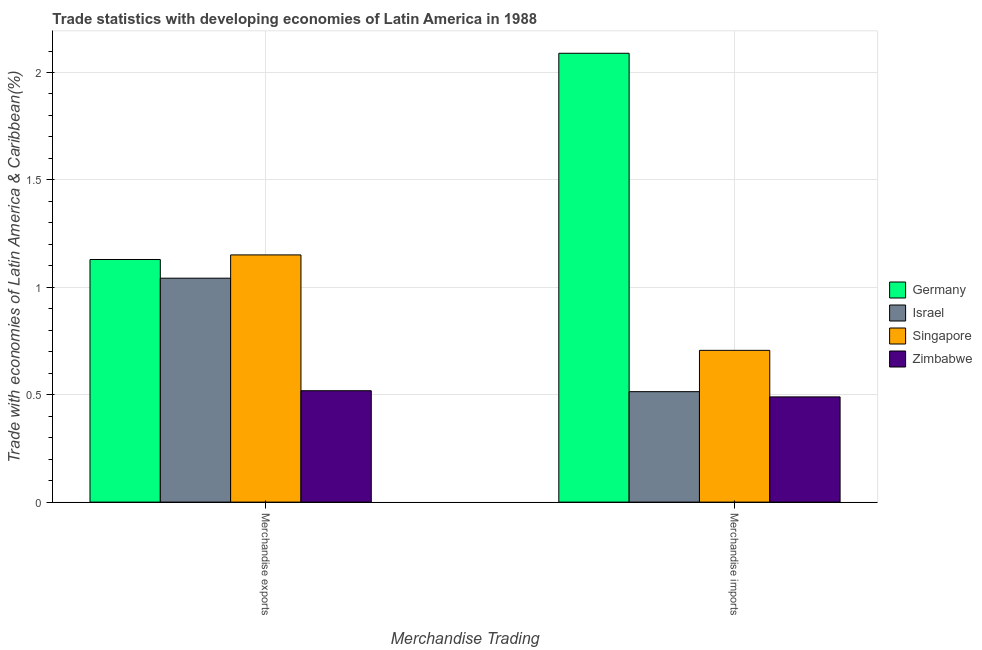How many bars are there on the 1st tick from the left?
Ensure brevity in your answer.  4. How many bars are there on the 1st tick from the right?
Your response must be concise. 4. What is the merchandise imports in Zimbabwe?
Provide a short and direct response. 0.49. Across all countries, what is the maximum merchandise exports?
Provide a short and direct response. 1.15. Across all countries, what is the minimum merchandise imports?
Make the answer very short. 0.49. In which country was the merchandise exports minimum?
Ensure brevity in your answer.  Zimbabwe. What is the total merchandise exports in the graph?
Your response must be concise. 3.84. What is the difference between the merchandise exports in Israel and that in Zimbabwe?
Offer a terse response. 0.52. What is the difference between the merchandise exports in Israel and the merchandise imports in Zimbabwe?
Keep it short and to the point. 0.55. What is the average merchandise imports per country?
Make the answer very short. 0.95. What is the difference between the merchandise exports and merchandise imports in Israel?
Offer a terse response. 0.53. In how many countries, is the merchandise imports greater than 1.4 %?
Make the answer very short. 1. What is the ratio of the merchandise exports in Israel to that in Germany?
Offer a very short reply. 0.92. Is the merchandise exports in Singapore less than that in Germany?
Keep it short and to the point. No. What does the 1st bar from the right in Merchandise imports represents?
Offer a very short reply. Zimbabwe. How many countries are there in the graph?
Offer a terse response. 4. What is the difference between two consecutive major ticks on the Y-axis?
Give a very brief answer. 0.5. Are the values on the major ticks of Y-axis written in scientific E-notation?
Offer a terse response. No. How are the legend labels stacked?
Your response must be concise. Vertical. What is the title of the graph?
Offer a terse response. Trade statistics with developing economies of Latin America in 1988. What is the label or title of the X-axis?
Give a very brief answer. Merchandise Trading. What is the label or title of the Y-axis?
Your response must be concise. Trade with economies of Latin America & Caribbean(%). What is the Trade with economies of Latin America & Caribbean(%) in Germany in Merchandise exports?
Your answer should be compact. 1.13. What is the Trade with economies of Latin America & Caribbean(%) in Israel in Merchandise exports?
Your response must be concise. 1.04. What is the Trade with economies of Latin America & Caribbean(%) of Singapore in Merchandise exports?
Offer a terse response. 1.15. What is the Trade with economies of Latin America & Caribbean(%) of Zimbabwe in Merchandise exports?
Provide a succinct answer. 0.52. What is the Trade with economies of Latin America & Caribbean(%) in Germany in Merchandise imports?
Give a very brief answer. 2.09. What is the Trade with economies of Latin America & Caribbean(%) in Israel in Merchandise imports?
Keep it short and to the point. 0.51. What is the Trade with economies of Latin America & Caribbean(%) in Singapore in Merchandise imports?
Offer a very short reply. 0.71. What is the Trade with economies of Latin America & Caribbean(%) of Zimbabwe in Merchandise imports?
Offer a very short reply. 0.49. Across all Merchandise Trading, what is the maximum Trade with economies of Latin America & Caribbean(%) of Germany?
Offer a terse response. 2.09. Across all Merchandise Trading, what is the maximum Trade with economies of Latin America & Caribbean(%) of Israel?
Ensure brevity in your answer.  1.04. Across all Merchandise Trading, what is the maximum Trade with economies of Latin America & Caribbean(%) in Singapore?
Your answer should be very brief. 1.15. Across all Merchandise Trading, what is the maximum Trade with economies of Latin America & Caribbean(%) of Zimbabwe?
Make the answer very short. 0.52. Across all Merchandise Trading, what is the minimum Trade with economies of Latin America & Caribbean(%) of Germany?
Your answer should be compact. 1.13. Across all Merchandise Trading, what is the minimum Trade with economies of Latin America & Caribbean(%) in Israel?
Keep it short and to the point. 0.51. Across all Merchandise Trading, what is the minimum Trade with economies of Latin America & Caribbean(%) of Singapore?
Offer a very short reply. 0.71. Across all Merchandise Trading, what is the minimum Trade with economies of Latin America & Caribbean(%) in Zimbabwe?
Your answer should be compact. 0.49. What is the total Trade with economies of Latin America & Caribbean(%) in Germany in the graph?
Give a very brief answer. 3.22. What is the total Trade with economies of Latin America & Caribbean(%) of Israel in the graph?
Offer a terse response. 1.56. What is the total Trade with economies of Latin America & Caribbean(%) in Singapore in the graph?
Make the answer very short. 1.86. What is the total Trade with economies of Latin America & Caribbean(%) in Zimbabwe in the graph?
Ensure brevity in your answer.  1.01. What is the difference between the Trade with economies of Latin America & Caribbean(%) in Germany in Merchandise exports and that in Merchandise imports?
Ensure brevity in your answer.  -0.96. What is the difference between the Trade with economies of Latin America & Caribbean(%) of Israel in Merchandise exports and that in Merchandise imports?
Make the answer very short. 0.53. What is the difference between the Trade with economies of Latin America & Caribbean(%) of Singapore in Merchandise exports and that in Merchandise imports?
Keep it short and to the point. 0.44. What is the difference between the Trade with economies of Latin America & Caribbean(%) in Zimbabwe in Merchandise exports and that in Merchandise imports?
Offer a very short reply. 0.03. What is the difference between the Trade with economies of Latin America & Caribbean(%) in Germany in Merchandise exports and the Trade with economies of Latin America & Caribbean(%) in Israel in Merchandise imports?
Your answer should be very brief. 0.62. What is the difference between the Trade with economies of Latin America & Caribbean(%) of Germany in Merchandise exports and the Trade with economies of Latin America & Caribbean(%) of Singapore in Merchandise imports?
Keep it short and to the point. 0.42. What is the difference between the Trade with economies of Latin America & Caribbean(%) in Germany in Merchandise exports and the Trade with economies of Latin America & Caribbean(%) in Zimbabwe in Merchandise imports?
Make the answer very short. 0.64. What is the difference between the Trade with economies of Latin America & Caribbean(%) of Israel in Merchandise exports and the Trade with economies of Latin America & Caribbean(%) of Singapore in Merchandise imports?
Provide a succinct answer. 0.34. What is the difference between the Trade with economies of Latin America & Caribbean(%) of Israel in Merchandise exports and the Trade with economies of Latin America & Caribbean(%) of Zimbabwe in Merchandise imports?
Ensure brevity in your answer.  0.55. What is the difference between the Trade with economies of Latin America & Caribbean(%) in Singapore in Merchandise exports and the Trade with economies of Latin America & Caribbean(%) in Zimbabwe in Merchandise imports?
Make the answer very short. 0.66. What is the average Trade with economies of Latin America & Caribbean(%) in Germany per Merchandise Trading?
Your answer should be very brief. 1.61. What is the average Trade with economies of Latin America & Caribbean(%) of Israel per Merchandise Trading?
Your answer should be very brief. 0.78. What is the average Trade with economies of Latin America & Caribbean(%) of Singapore per Merchandise Trading?
Your answer should be compact. 0.93. What is the average Trade with economies of Latin America & Caribbean(%) of Zimbabwe per Merchandise Trading?
Your answer should be compact. 0.5. What is the difference between the Trade with economies of Latin America & Caribbean(%) of Germany and Trade with economies of Latin America & Caribbean(%) of Israel in Merchandise exports?
Give a very brief answer. 0.09. What is the difference between the Trade with economies of Latin America & Caribbean(%) of Germany and Trade with economies of Latin America & Caribbean(%) of Singapore in Merchandise exports?
Your answer should be compact. -0.02. What is the difference between the Trade with economies of Latin America & Caribbean(%) of Germany and Trade with economies of Latin America & Caribbean(%) of Zimbabwe in Merchandise exports?
Offer a very short reply. 0.61. What is the difference between the Trade with economies of Latin America & Caribbean(%) in Israel and Trade with economies of Latin America & Caribbean(%) in Singapore in Merchandise exports?
Your answer should be compact. -0.11. What is the difference between the Trade with economies of Latin America & Caribbean(%) of Israel and Trade with economies of Latin America & Caribbean(%) of Zimbabwe in Merchandise exports?
Ensure brevity in your answer.  0.52. What is the difference between the Trade with economies of Latin America & Caribbean(%) in Singapore and Trade with economies of Latin America & Caribbean(%) in Zimbabwe in Merchandise exports?
Give a very brief answer. 0.63. What is the difference between the Trade with economies of Latin America & Caribbean(%) in Germany and Trade with economies of Latin America & Caribbean(%) in Israel in Merchandise imports?
Give a very brief answer. 1.58. What is the difference between the Trade with economies of Latin America & Caribbean(%) of Germany and Trade with economies of Latin America & Caribbean(%) of Singapore in Merchandise imports?
Provide a short and direct response. 1.38. What is the difference between the Trade with economies of Latin America & Caribbean(%) of Germany and Trade with economies of Latin America & Caribbean(%) of Zimbabwe in Merchandise imports?
Offer a very short reply. 1.6. What is the difference between the Trade with economies of Latin America & Caribbean(%) in Israel and Trade with economies of Latin America & Caribbean(%) in Singapore in Merchandise imports?
Your response must be concise. -0.19. What is the difference between the Trade with economies of Latin America & Caribbean(%) in Israel and Trade with economies of Latin America & Caribbean(%) in Zimbabwe in Merchandise imports?
Give a very brief answer. 0.02. What is the difference between the Trade with economies of Latin America & Caribbean(%) in Singapore and Trade with economies of Latin America & Caribbean(%) in Zimbabwe in Merchandise imports?
Your answer should be compact. 0.22. What is the ratio of the Trade with economies of Latin America & Caribbean(%) of Germany in Merchandise exports to that in Merchandise imports?
Your answer should be very brief. 0.54. What is the ratio of the Trade with economies of Latin America & Caribbean(%) in Israel in Merchandise exports to that in Merchandise imports?
Keep it short and to the point. 2.03. What is the ratio of the Trade with economies of Latin America & Caribbean(%) of Singapore in Merchandise exports to that in Merchandise imports?
Offer a terse response. 1.63. What is the ratio of the Trade with economies of Latin America & Caribbean(%) in Zimbabwe in Merchandise exports to that in Merchandise imports?
Make the answer very short. 1.06. What is the difference between the highest and the second highest Trade with economies of Latin America & Caribbean(%) in Germany?
Provide a succinct answer. 0.96. What is the difference between the highest and the second highest Trade with economies of Latin America & Caribbean(%) in Israel?
Keep it short and to the point. 0.53. What is the difference between the highest and the second highest Trade with economies of Latin America & Caribbean(%) of Singapore?
Your answer should be compact. 0.44. What is the difference between the highest and the second highest Trade with economies of Latin America & Caribbean(%) of Zimbabwe?
Provide a short and direct response. 0.03. What is the difference between the highest and the lowest Trade with economies of Latin America & Caribbean(%) of Germany?
Provide a succinct answer. 0.96. What is the difference between the highest and the lowest Trade with economies of Latin America & Caribbean(%) of Israel?
Offer a very short reply. 0.53. What is the difference between the highest and the lowest Trade with economies of Latin America & Caribbean(%) of Singapore?
Ensure brevity in your answer.  0.44. What is the difference between the highest and the lowest Trade with economies of Latin America & Caribbean(%) of Zimbabwe?
Offer a terse response. 0.03. 